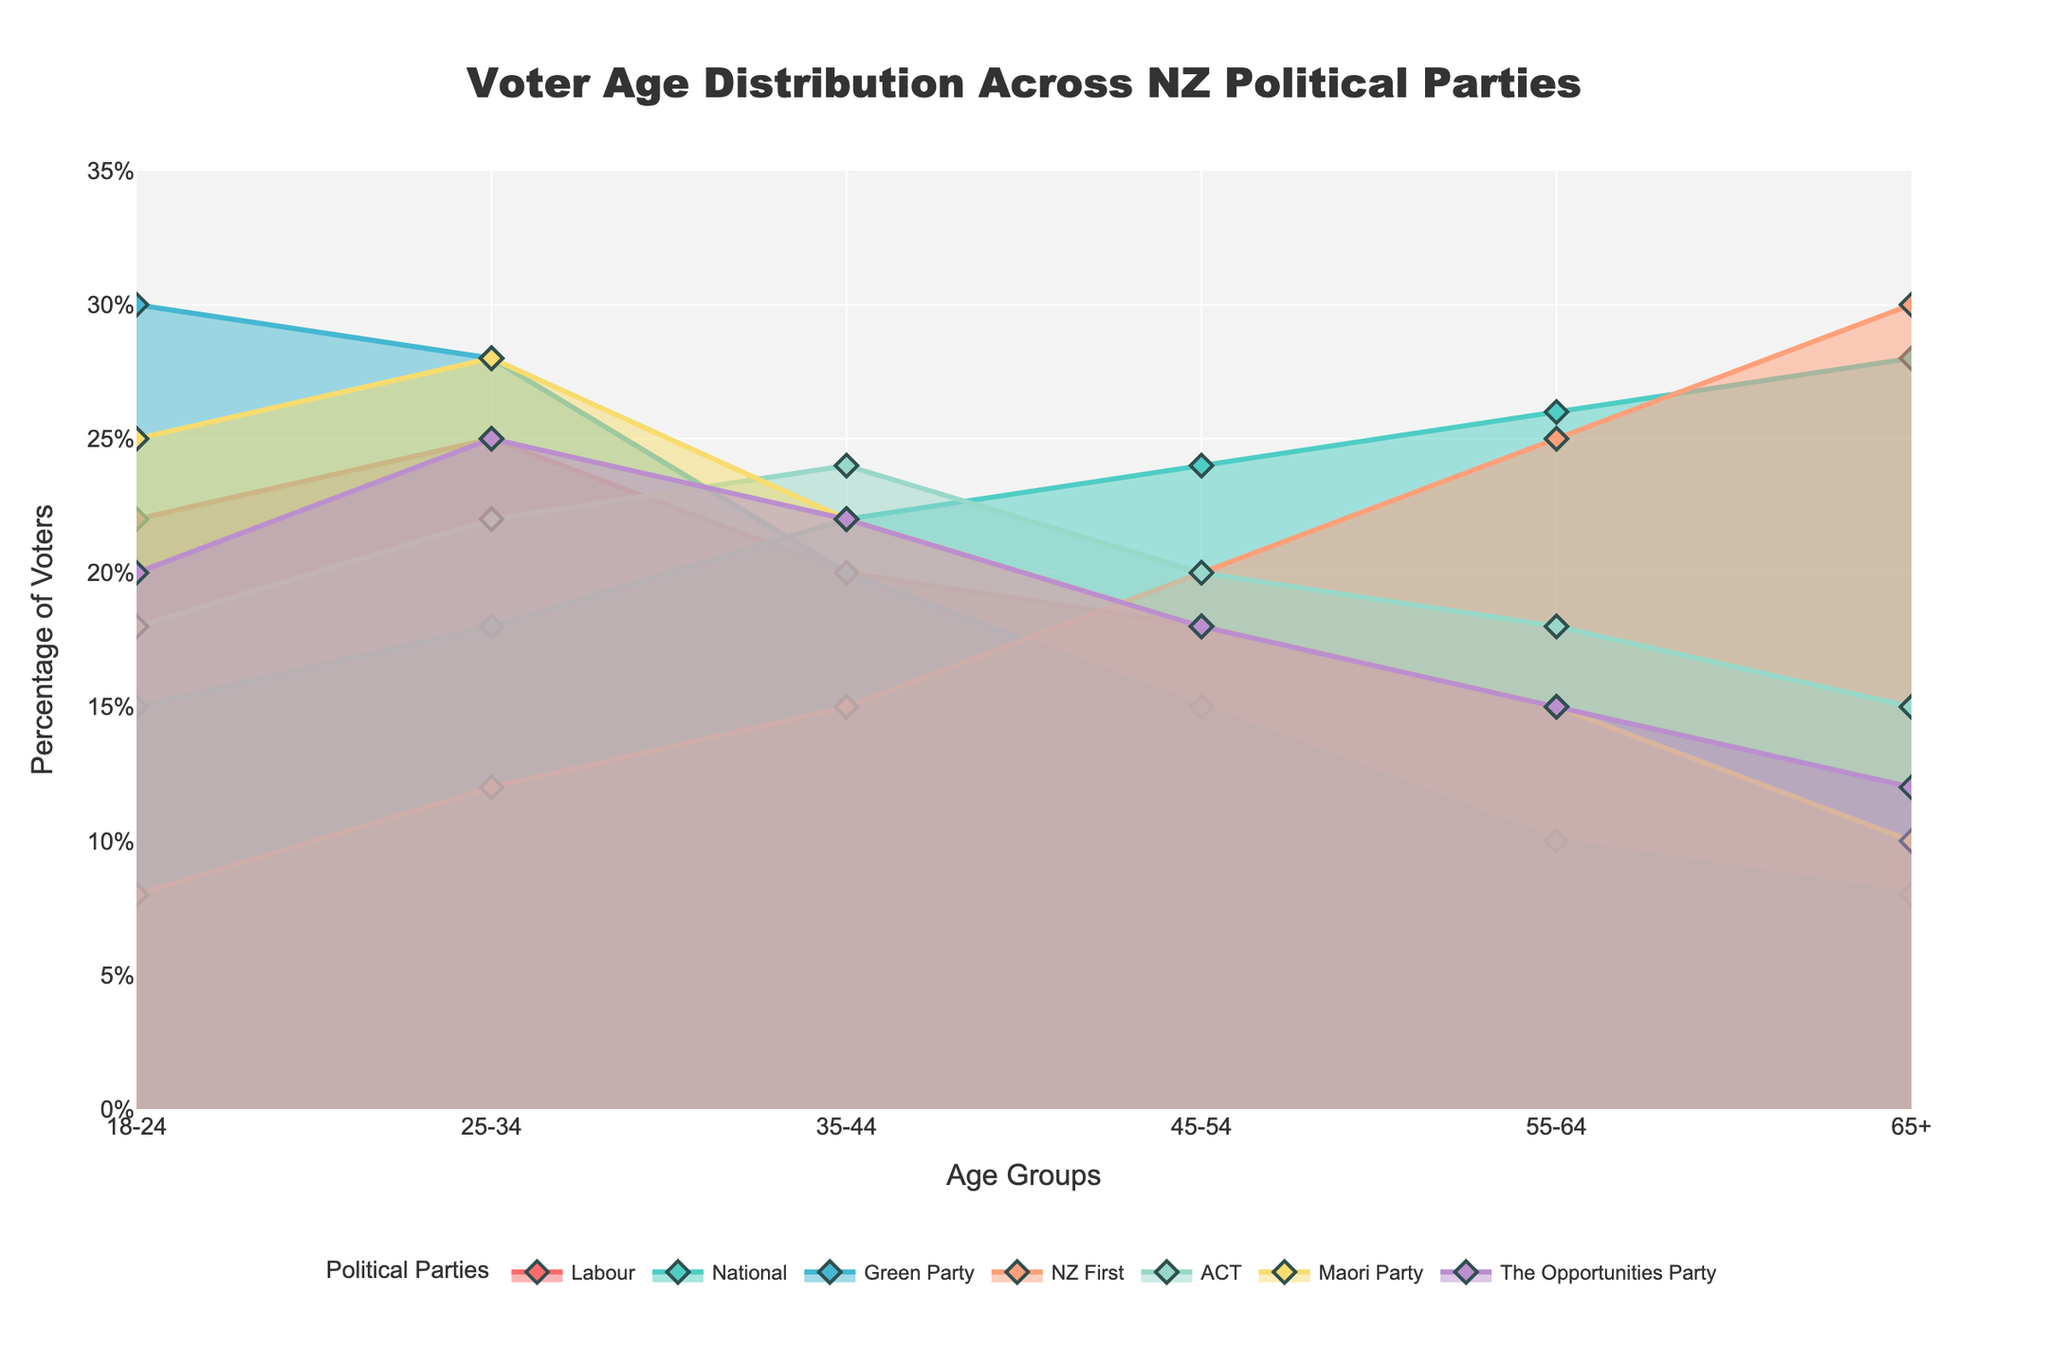What is the range of voter percentages for the Green Party across different age groups? To find the range, identify the Green Party's voter percentages from the plot: 30, 28, 20, 15, 10, 8. Subtract the lowest percentage from the highest: 30% - 8% = 22%.
Answer: 22% Which age group has the highest percentage of National party voters? Review the plot to find the peak National party voter percentage across age groups: 65+, which has the highest at 28%.
Answer: 65+ How does the voter percentage for the 18-24 age group compare between Labour and ACT parties? From the plot, observe the 18-24 voter percentages: Labour is 22% and ACT is 18%. Labour has a higher percentage.
Answer: Labour has a higher percentage What is the combined percentage of voters aged 45-54 for NZ First and ACT parties? Identify the percentages from the plot: NZ First is 20%, ACT is 20%. Summing these gives 20% + 20% = 40%.
Answer: 40% Which political party has the least fluctuation in voter percentages across all age groups? Analyze the plot for each party's voter percentage stability: ACT's percentages are closely grouped with a small range of fluctuations (24% to 15%).
Answer: ACT Which age group shows a lower voter percentage for Labour compared to The Opportunities Party? Compare the plots for Labour and The Opportunities Party: The age group 65+ for Labour is 12% and for The Opportunities Party is 12%. Another comparison shows the 25-34 age group, with Labour at 25% and The Opportunities Party at 25%. The 35-44 age group also compares at 20% for Labour and The Opportunities Party. Thus, no lower percentages are present in the visible data.
Answer: None What is the difference in voter percentage between the youngest (18-24) and oldest (65+) age groups for NZ First? For NZ First, the 18-24 percentage is 8% and the 65+ is 30%. The difference is 30% - 8% = 22%.
Answer: 22% Out of all the age groups, which one shows the highest percentage for any political party? Survey the plot across all parties and age groups: The Green Party has the highest at 30% for the 18-24 age group.
Answer: 30% for Green Party, 18-24 Which age group has an equal voter percentage for both Labour and The Opportunities Party? Check the plot for overlapping percentages: Both have 22% for the 35-44 age group.
Answer: 35-44 In the 55-64 age group, which party has the closest voter percentage to the National party? For the 55-64 age group, National is at 26%. NZ First is closest at 25%.
Answer: NZ First 